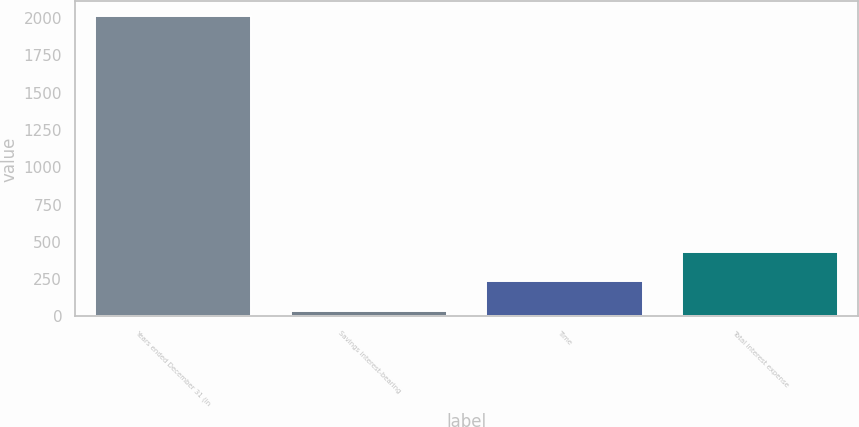Convert chart. <chart><loc_0><loc_0><loc_500><loc_500><bar_chart><fcel>Years ended December 31 (in<fcel>Savings interest-bearing<fcel>Time<fcel>Total interest expense<nl><fcel>2012<fcel>38.7<fcel>236.03<fcel>433.36<nl></chart> 